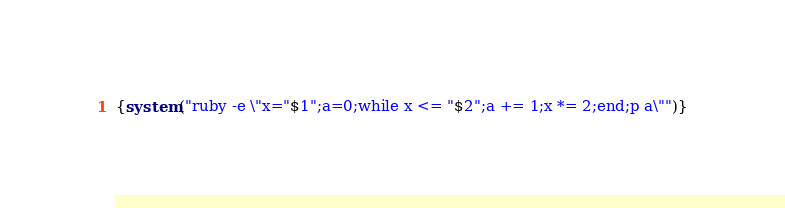<code> <loc_0><loc_0><loc_500><loc_500><_Awk_>{system("ruby -e \"x="$1";a=0;while x <= "$2";a += 1;x *= 2;end;p a\"")}
</code> 